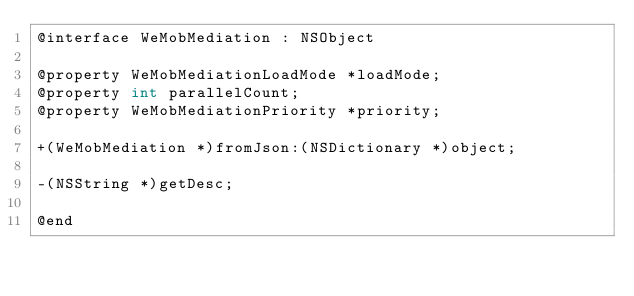<code> <loc_0><loc_0><loc_500><loc_500><_C_>@interface WeMobMediation : NSObject

@property WeMobMediationLoadMode *loadMode;
@property int parallelCount;
@property WeMobMediationPriority *priority;

+(WeMobMediation *)fromJson:(NSDictionary *)object;

-(NSString *)getDesc;

@end
</code> 